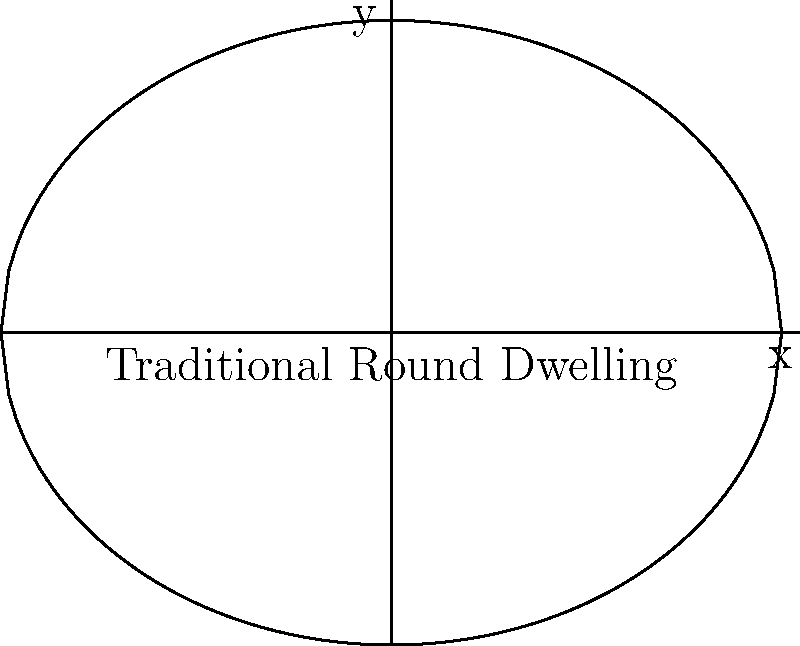A traditional round dwelling in an indigenous community can be modeled using an ellipse. If the dwelling has a major axis of 10 meters and a minor axis of 8 meters, what is the eccentricity of the ellipse? How might this shape contribute to the dwelling's sustainability in terms of heat retention and material efficiency? To solve this problem, we'll follow these steps:

1. Recall the formula for eccentricity of an ellipse:
   $$e = \sqrt{1 - \frac{b^2}{a^2}}$$
   where $a$ is the semi-major axis and $b$ is the semi-minor axis.

2. Given information:
   - Major axis = 10 meters, so $a = 5$ meters
   - Minor axis = 8 meters, so $b = 4$ meters

3. Plug these values into the eccentricity formula:
   $$e = \sqrt{1 - \frac{4^2}{5^2}}$$

4. Simplify:
   $$e = \sqrt{1 - \frac{16}{25}} = \sqrt{\frac{25-16}{25}} = \sqrt{\frac{9}{25}} = \frac{3}{5} = 0.6$$

5. Sustainability aspects:
   - Heat retention: The rounded shape minimizes the surface area to volume ratio, reducing heat loss and improving energy efficiency.
   - Material efficiency: The elliptical shape requires less building material compared to rectangular structures of similar volume, promoting resource conservation.
   - Structural stability: The curved shape distributes forces evenly, potentially increasing the dwelling's resilience to environmental stresses.
   - Cultural significance: The shape may align with traditional designs, supporting cultural preservation alongside sustainable development.
Answer: Eccentricity: 0.6; Shape contributes to heat retention and material efficiency. 